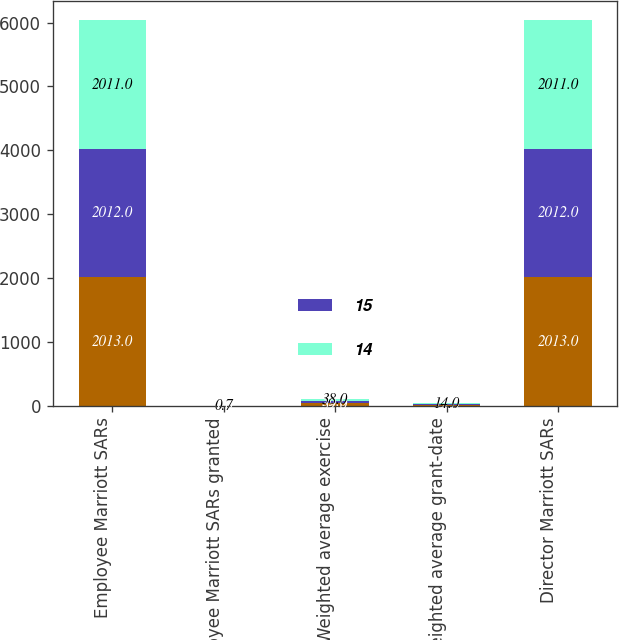Convert chart. <chart><loc_0><loc_0><loc_500><loc_500><stacked_bar_chart><ecel><fcel>Employee Marriott SARs<fcel>Employee Marriott SARs granted<fcel>Weighted average exercise<fcel>Weighted average grant-date<fcel>Director Marriott SARs<nl><fcel>nan<fcel>2013<fcel>0.7<fcel>39<fcel>13<fcel>2013<nl><fcel>15<fcel>2012<fcel>1<fcel>35<fcel>12<fcel>2012<nl><fcel>14<fcel>2011<fcel>0.7<fcel>38<fcel>14<fcel>2011<nl></chart> 